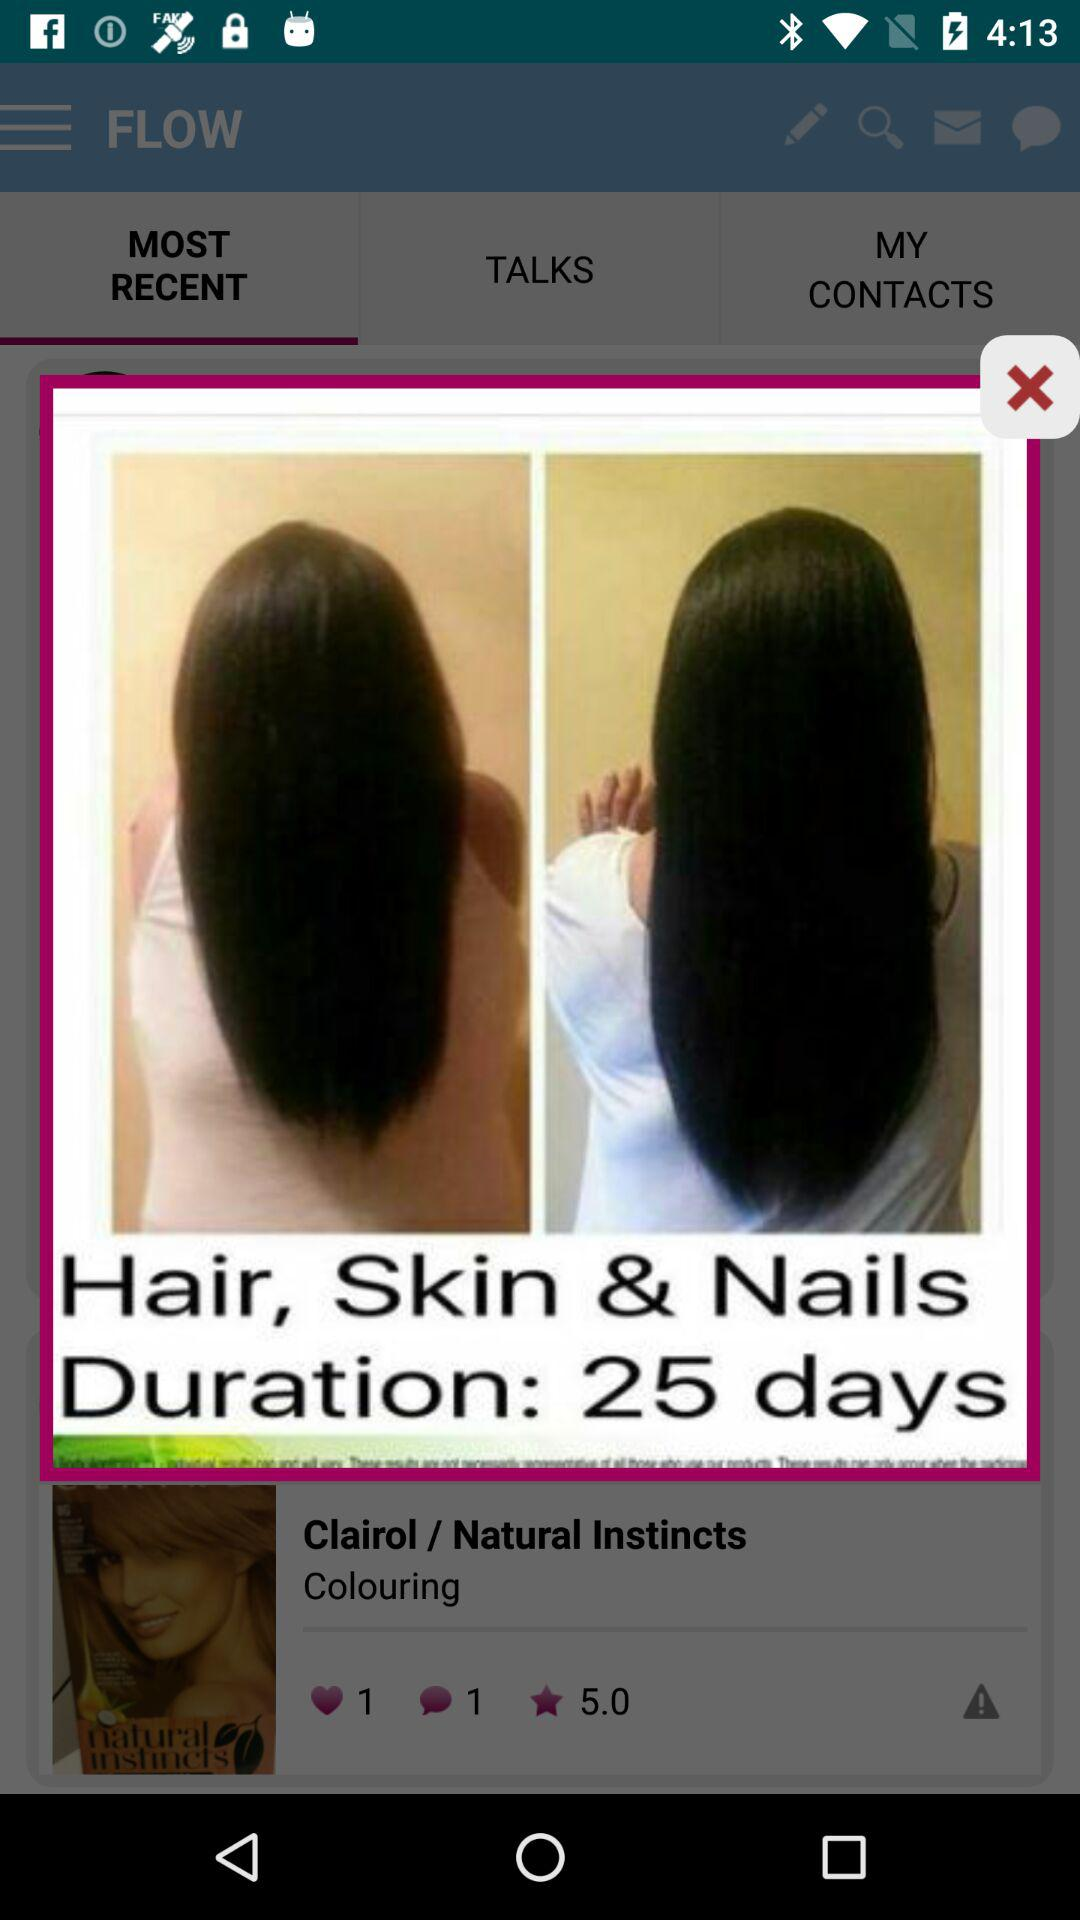How many likes are there of "Clairol / Natural Instincts"? There is 1 like of "Clairol / Natural Instincts". 